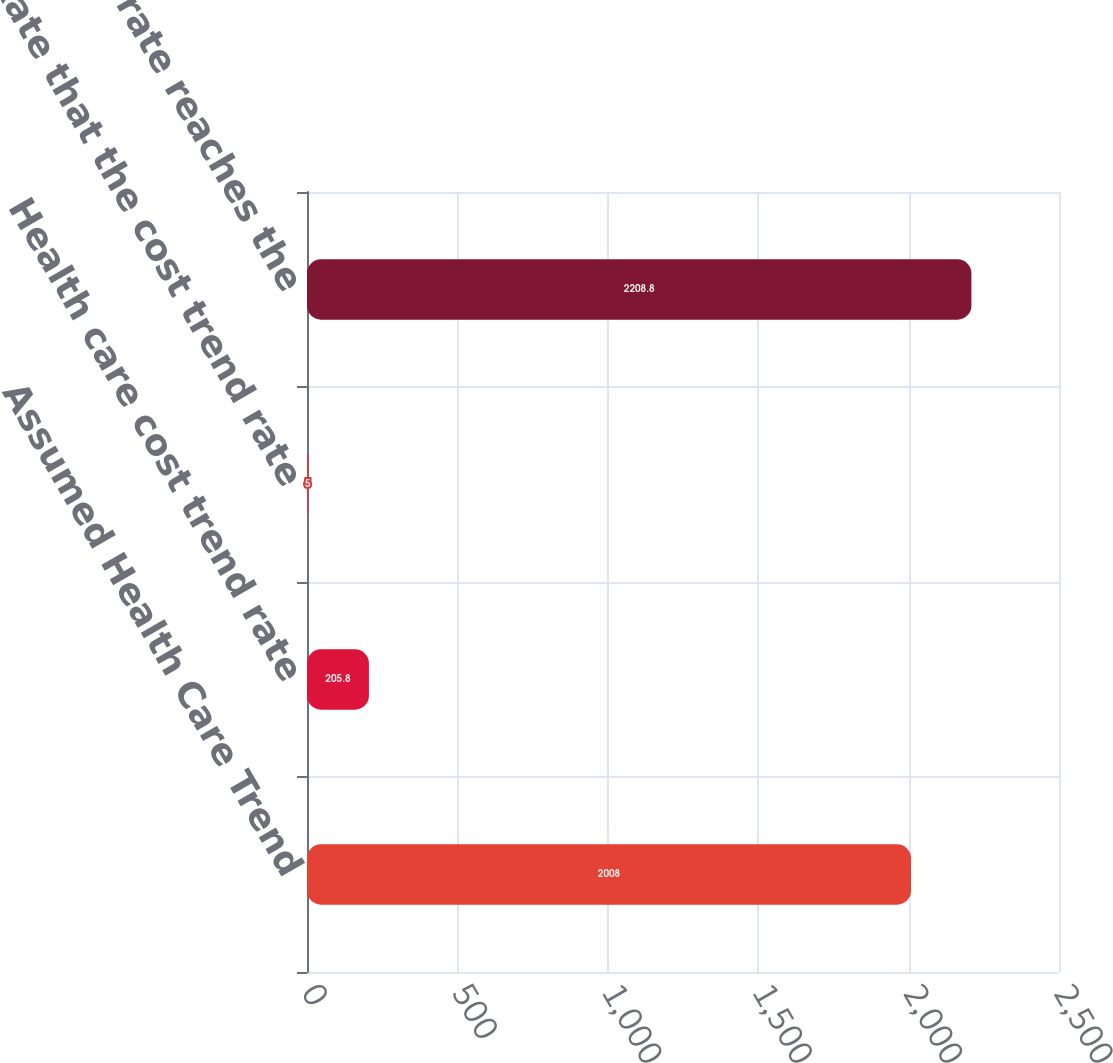Convert chart. <chart><loc_0><loc_0><loc_500><loc_500><bar_chart><fcel>Assumed Health Care Trend<fcel>Health care cost trend rate<fcel>Rate that the cost trend rate<fcel>Year that the rate reaches the<nl><fcel>2008<fcel>205.8<fcel>5<fcel>2208.8<nl></chart> 